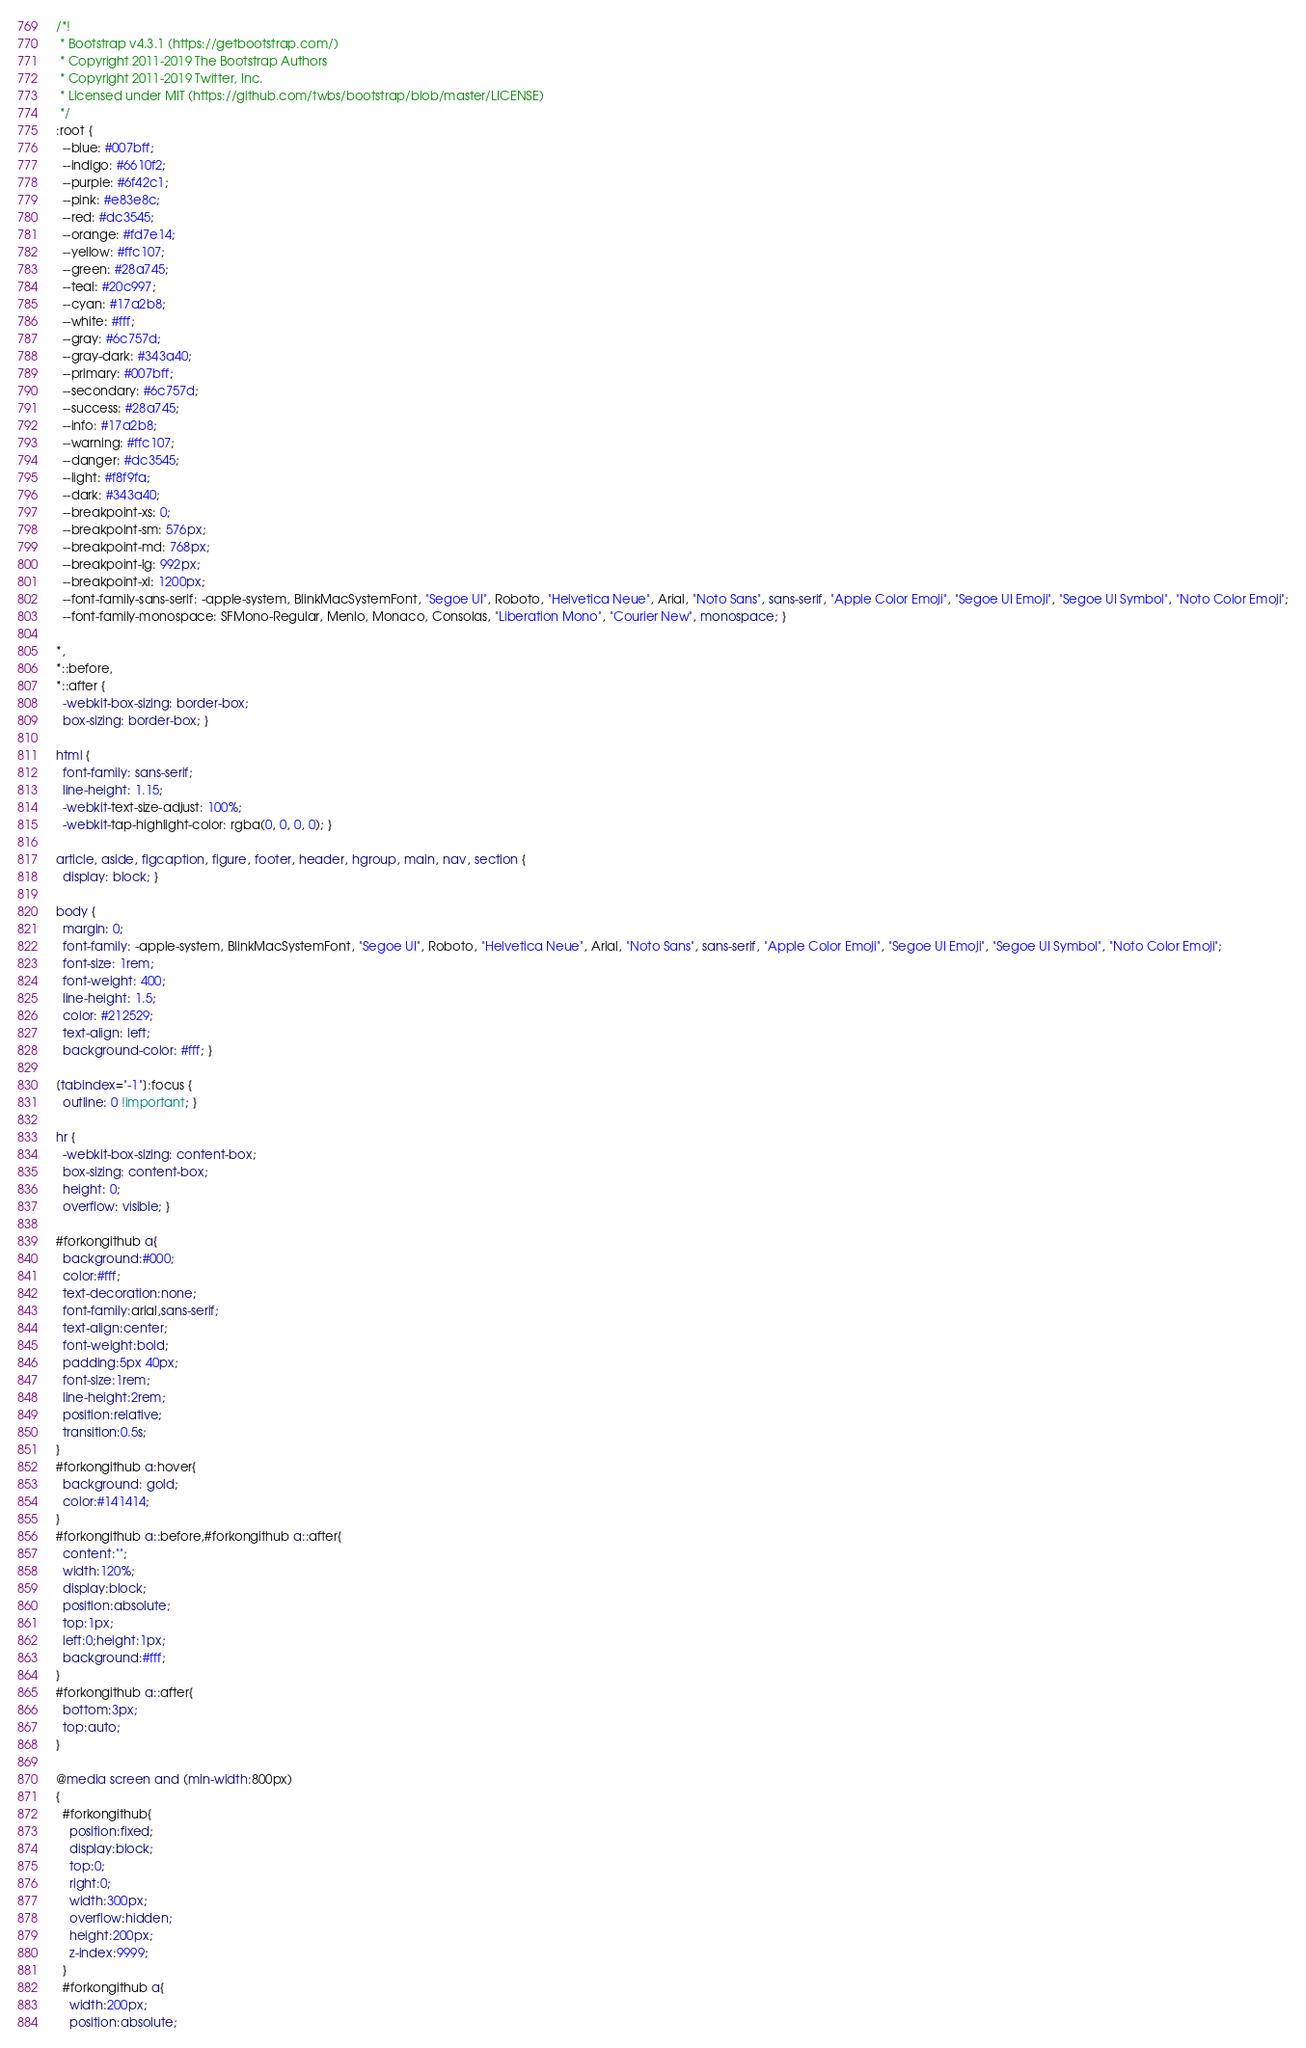Convert code to text. <code><loc_0><loc_0><loc_500><loc_500><_CSS_>/*!
 * Bootstrap v4.3.1 (https://getbootstrap.com/)
 * Copyright 2011-2019 The Bootstrap Authors
 * Copyright 2011-2019 Twitter, Inc.
 * Licensed under MIT (https://github.com/twbs/bootstrap/blob/master/LICENSE)
 */
:root {
  --blue: #007bff;
  --indigo: #6610f2;
  --purple: #6f42c1;
  --pink: #e83e8c;
  --red: #dc3545;
  --orange: #fd7e14;
  --yellow: #ffc107;
  --green: #28a745;
  --teal: #20c997;
  --cyan: #17a2b8;
  --white: #fff;
  --gray: #6c757d;
  --gray-dark: #343a40;
  --primary: #007bff;
  --secondary: #6c757d;
  --success: #28a745;
  --info: #17a2b8;
  --warning: #ffc107;
  --danger: #dc3545;
  --light: #f8f9fa;
  --dark: #343a40;
  --breakpoint-xs: 0;
  --breakpoint-sm: 576px;
  --breakpoint-md: 768px;
  --breakpoint-lg: 992px;
  --breakpoint-xl: 1200px;
  --font-family-sans-serif: -apple-system, BlinkMacSystemFont, "Segoe UI", Roboto, "Helvetica Neue", Arial, "Noto Sans", sans-serif, "Apple Color Emoji", "Segoe UI Emoji", "Segoe UI Symbol", "Noto Color Emoji";
  --font-family-monospace: SFMono-Regular, Menlo, Monaco, Consolas, "Liberation Mono", "Courier New", monospace; }

*,
*::before,
*::after {
  -webkit-box-sizing: border-box;
  box-sizing: border-box; }

html {
  font-family: sans-serif;
  line-height: 1.15;
  -webkit-text-size-adjust: 100%;
  -webkit-tap-highlight-color: rgba(0, 0, 0, 0); }

article, aside, figcaption, figure, footer, header, hgroup, main, nav, section {
  display: block; }

body {
  margin: 0;
  font-family: -apple-system, BlinkMacSystemFont, "Segoe UI", Roboto, "Helvetica Neue", Arial, "Noto Sans", sans-serif, "Apple Color Emoji", "Segoe UI Emoji", "Segoe UI Symbol", "Noto Color Emoji";
  font-size: 1rem;
  font-weight: 400;
  line-height: 1.5;
  color: #212529;
  text-align: left;
  background-color: #fff; }

[tabindex="-1"]:focus {
  outline: 0 !important; }

hr {
  -webkit-box-sizing: content-box;
  box-sizing: content-box;
  height: 0;
  overflow: visible; }

#forkongithub a{
  background:#000;
  color:#fff;
  text-decoration:none;
  font-family:arial,sans-serif;
  text-align:center;
  font-weight:bold;
  padding:5px 40px;
  font-size:1rem;
  line-height:2rem;
  position:relative;
  transition:0.5s;
}
#forkongithub a:hover{
  background: gold;
  color:#141414;
}
#forkongithub a::before,#forkongithub a::after{
  content:"";
  width:120%;
  display:block;
  position:absolute;
  top:1px;
  left:0;height:1px;
  background:#fff;
}
#forkongithub a::after{
  bottom:3px;
  top:auto;
}

@media screen and (min-width:800px)
{
  #forkongithub{
    position:fixed;
    display:block;
    top:0;
    right:0;
    width:300px;
    overflow:hidden;
    height:200px;
    z-index:9999;
  }
  #forkongithub a{
    width:200px;
    position:absolute;</code> 